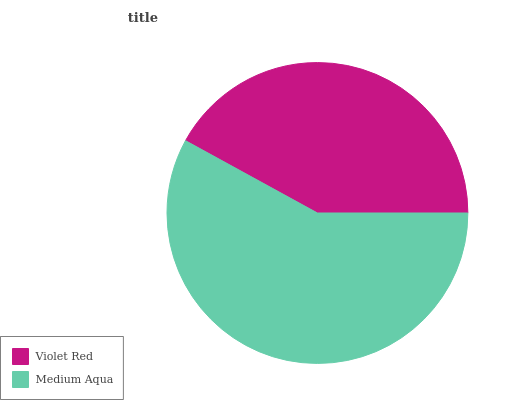Is Violet Red the minimum?
Answer yes or no. Yes. Is Medium Aqua the maximum?
Answer yes or no. Yes. Is Medium Aqua the minimum?
Answer yes or no. No. Is Medium Aqua greater than Violet Red?
Answer yes or no. Yes. Is Violet Red less than Medium Aqua?
Answer yes or no. Yes. Is Violet Red greater than Medium Aqua?
Answer yes or no. No. Is Medium Aqua less than Violet Red?
Answer yes or no. No. Is Medium Aqua the high median?
Answer yes or no. Yes. Is Violet Red the low median?
Answer yes or no. Yes. Is Violet Red the high median?
Answer yes or no. No. Is Medium Aqua the low median?
Answer yes or no. No. 